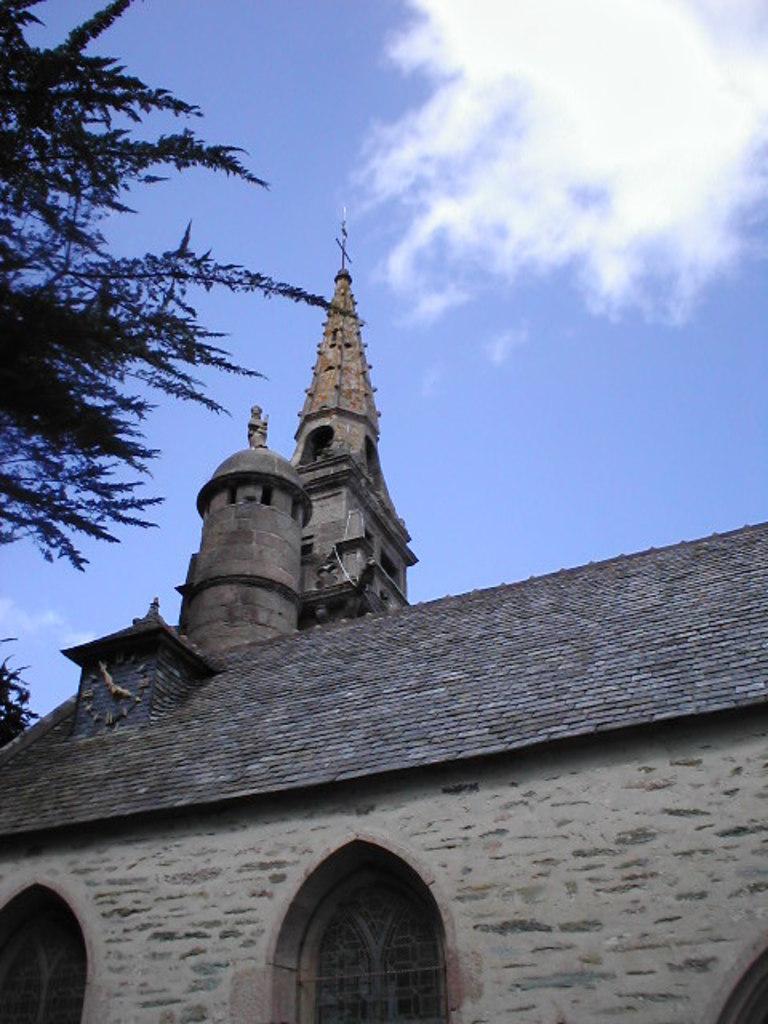Please provide a concise description of this image. There is a building with windows. On the roof of the building there is a clock. On the left side there is a tree. In the background there is sky with clouds. 